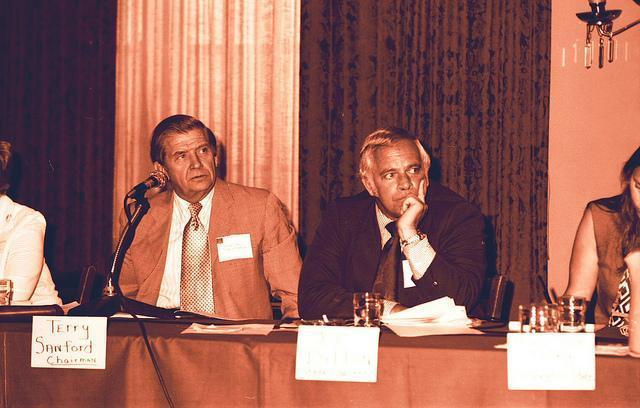How many people are here?
Give a very brief answer. 4. How many people can be seen?
Give a very brief answer. 4. 